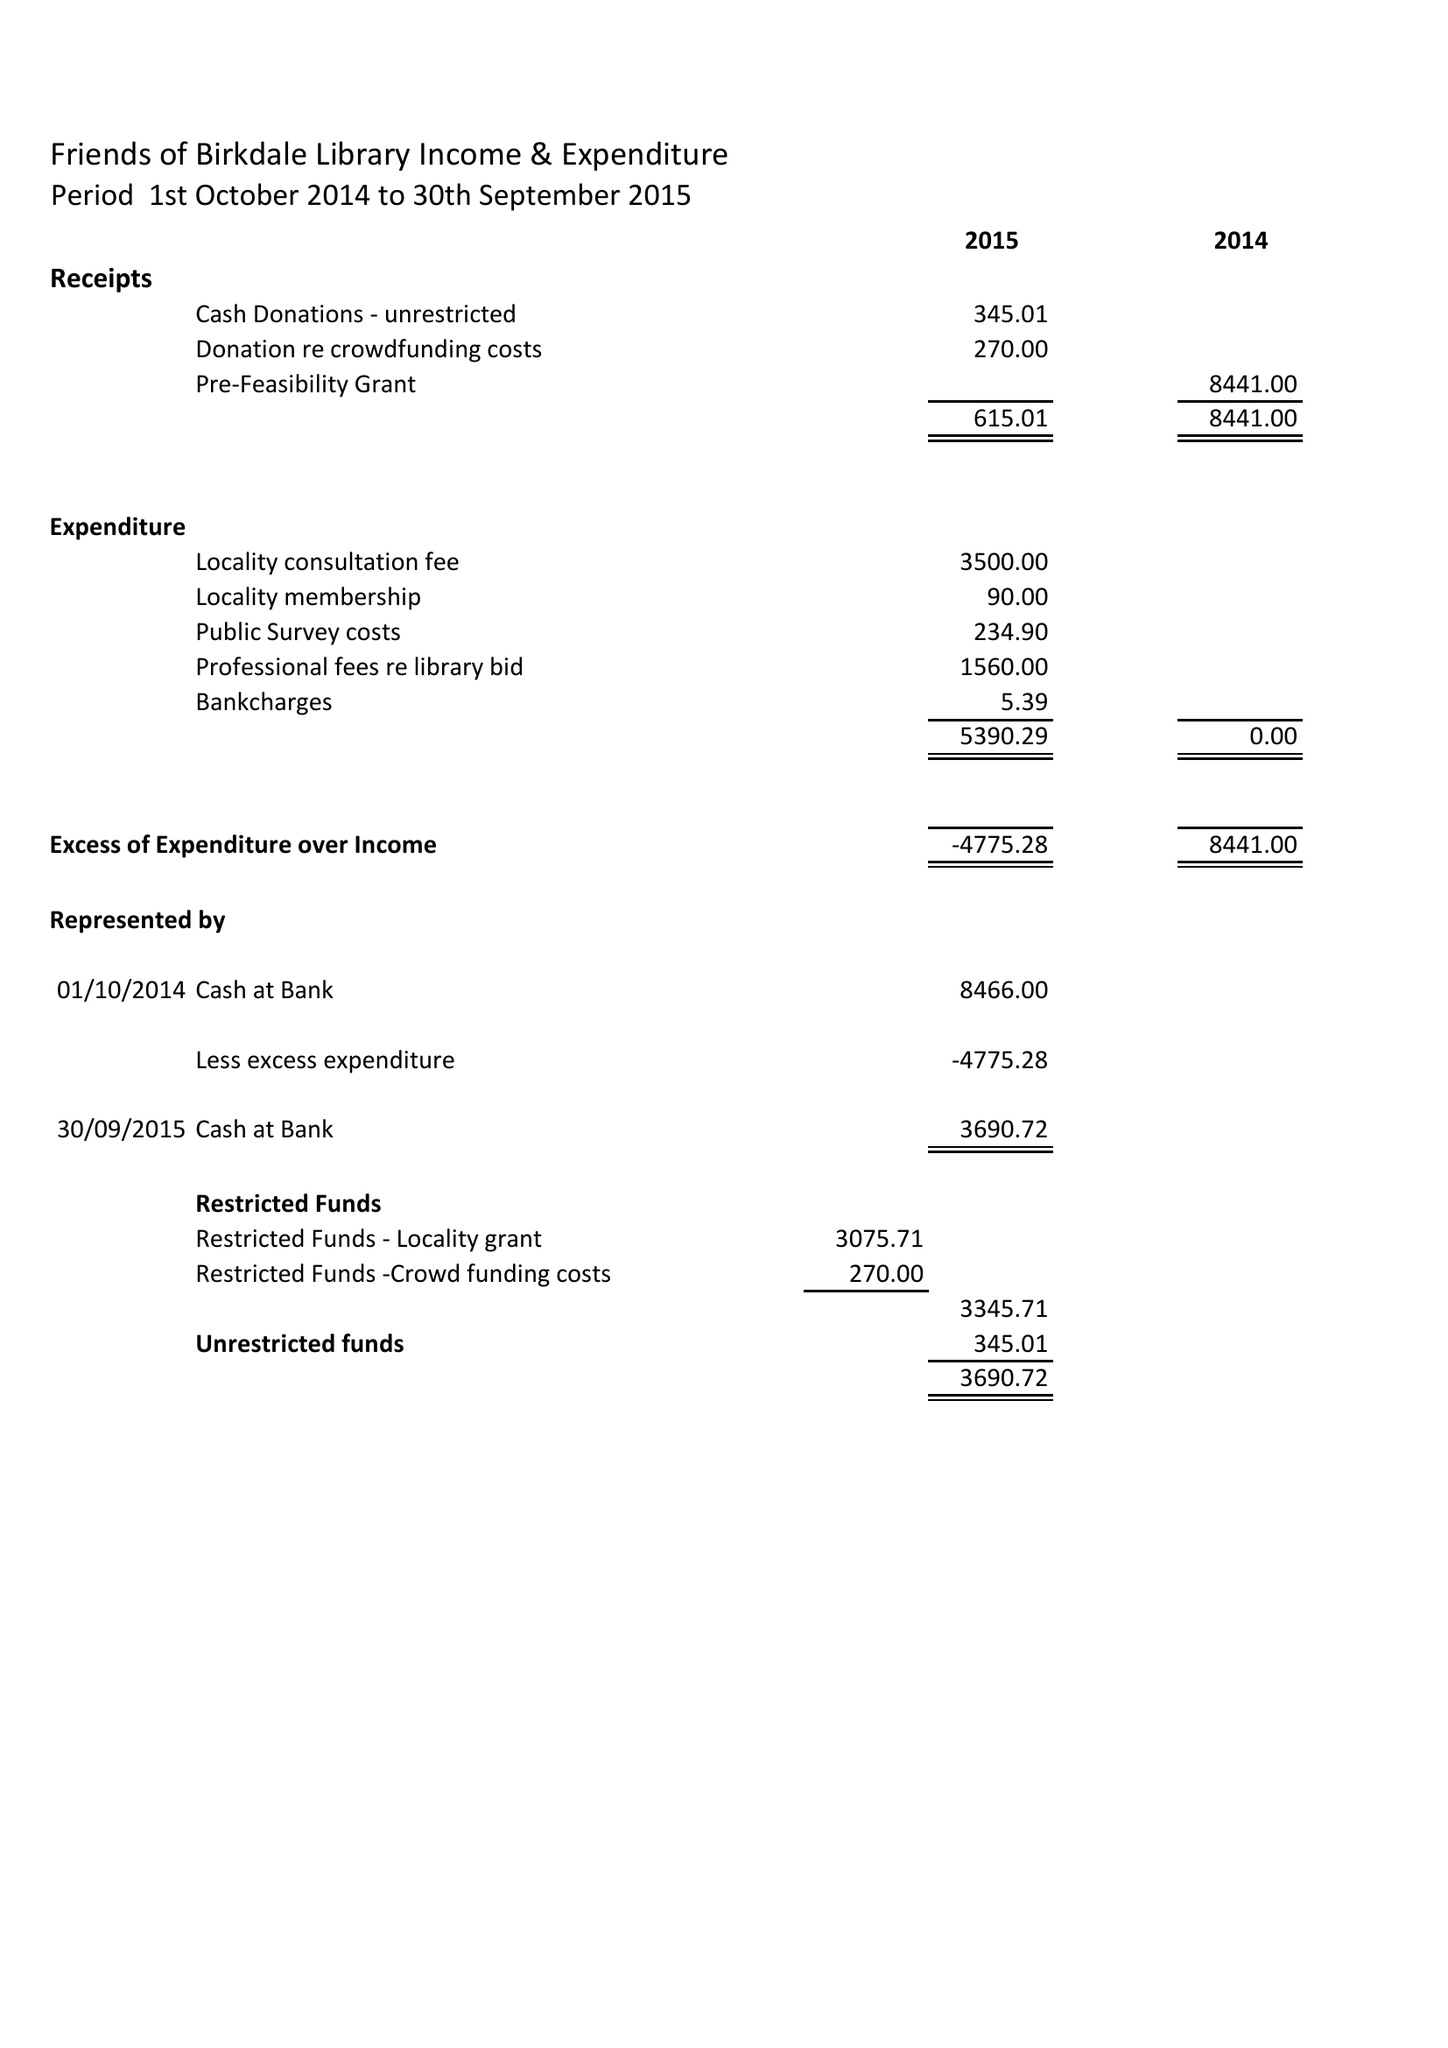What is the value for the charity_name?
Answer the question using a single word or phrase. Birkdale Community Hub and Library 